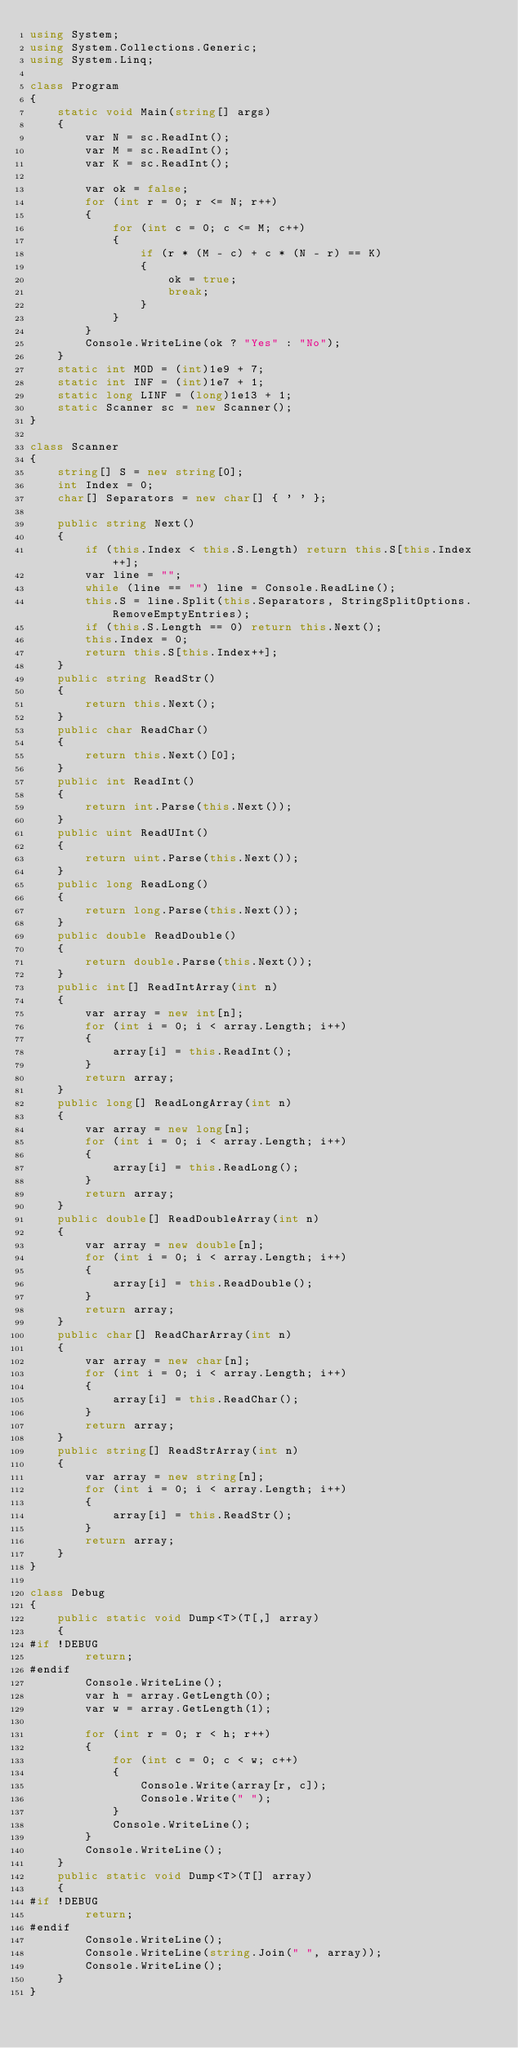<code> <loc_0><loc_0><loc_500><loc_500><_C#_>using System;
using System.Collections.Generic;
using System.Linq;

class Program
{
    static void Main(string[] args)
    {
        var N = sc.ReadInt();
        var M = sc.ReadInt();
        var K = sc.ReadInt();

        var ok = false;
        for (int r = 0; r <= N; r++)
        {
            for (int c = 0; c <= M; c++)
            {
                if (r * (M - c) + c * (N - r) == K)
                {
                    ok = true;
                    break;
                }
            }
        }
        Console.WriteLine(ok ? "Yes" : "No");
    }
    static int MOD = (int)1e9 + 7;
    static int INF = (int)1e7 + 1;
    static long LINF = (long)1e13 + 1;
    static Scanner sc = new Scanner();
}

class Scanner
{
    string[] S = new string[0];
    int Index = 0;
    char[] Separators = new char[] { ' ' };

    public string Next()
    {
        if (this.Index < this.S.Length) return this.S[this.Index++];
        var line = "";
        while (line == "") line = Console.ReadLine();
        this.S = line.Split(this.Separators, StringSplitOptions.RemoveEmptyEntries);
        if (this.S.Length == 0) return this.Next();
        this.Index = 0;
        return this.S[this.Index++];
    }
    public string ReadStr()
    {
        return this.Next();
    }
    public char ReadChar()
    {
        return this.Next()[0];
    }
    public int ReadInt()
    {
        return int.Parse(this.Next());
    }
    public uint ReadUInt()
    {
        return uint.Parse(this.Next());
    }
    public long ReadLong()
    {
        return long.Parse(this.Next());
    }
    public double ReadDouble()
    {
        return double.Parse(this.Next());
    }
    public int[] ReadIntArray(int n)
    {
        var array = new int[n];
        for (int i = 0; i < array.Length; i++)
        {
            array[i] = this.ReadInt();
        }
        return array;
    }
    public long[] ReadLongArray(int n)
    {
        var array = new long[n];
        for (int i = 0; i < array.Length; i++)
        {
            array[i] = this.ReadLong();
        }
        return array;
    }
    public double[] ReadDoubleArray(int n)
    {
        var array = new double[n];
        for (int i = 0; i < array.Length; i++)
        {
            array[i] = this.ReadDouble();
        }
        return array;
    }
    public char[] ReadCharArray(int n)
    {
        var array = new char[n];
        for (int i = 0; i < array.Length; i++)
        {
            array[i] = this.ReadChar();
        }
        return array;
    }
    public string[] ReadStrArray(int n)
    {
        var array = new string[n];
        for (int i = 0; i < array.Length; i++)
        {
            array[i] = this.ReadStr();
        }
        return array;
    }
}

class Debug
{
    public static void Dump<T>(T[,] array)
    {
#if !DEBUG
        return;
#endif
        Console.WriteLine();
        var h = array.GetLength(0);
        var w = array.GetLength(1);

        for (int r = 0; r < h; r++)
        {
            for (int c = 0; c < w; c++)
            {
                Console.Write(array[r, c]);
                Console.Write(" ");
            }
            Console.WriteLine();
        }
        Console.WriteLine();
    }
    public static void Dump<T>(T[] array)
    {
#if !DEBUG
        return;
#endif
        Console.WriteLine();
        Console.WriteLine(string.Join(" ", array));
        Console.WriteLine();
    }
}
</code> 